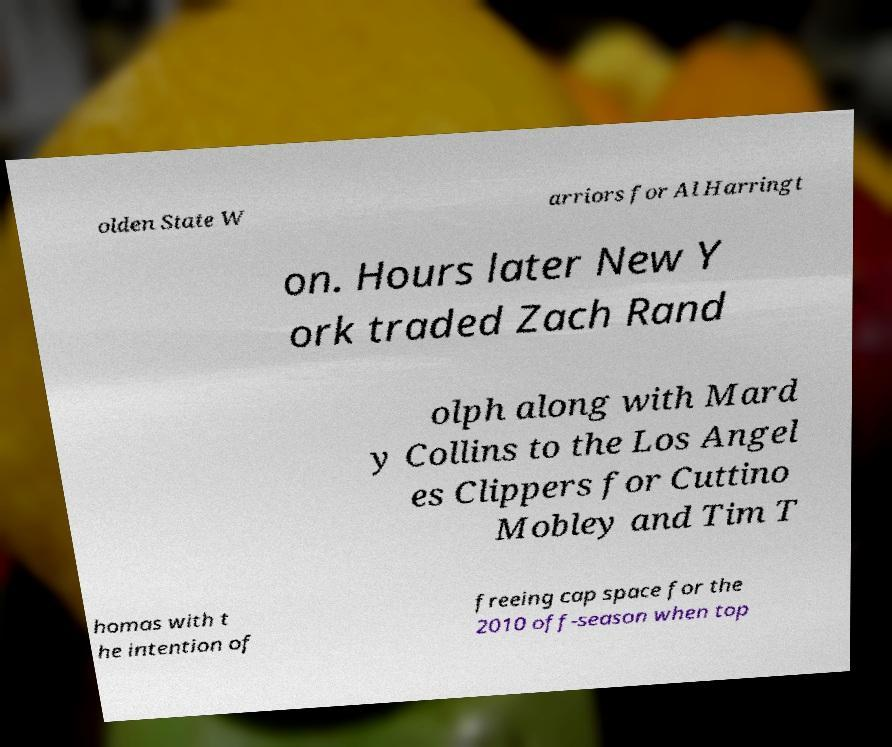For documentation purposes, I need the text within this image transcribed. Could you provide that? olden State W arriors for Al Harringt on. Hours later New Y ork traded Zach Rand olph along with Mard y Collins to the Los Angel es Clippers for Cuttino Mobley and Tim T homas with t he intention of freeing cap space for the 2010 off-season when top 